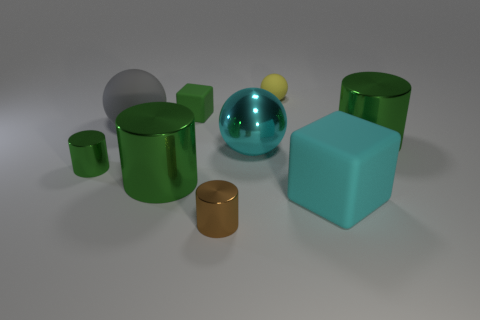How many small cylinders have the same color as the small block?
Provide a succinct answer. 1. What material is the large gray object?
Give a very brief answer. Rubber. Is the large shiny ball the same color as the big rubber cube?
Offer a terse response. Yes. There is a ball that is the same color as the large rubber block; what size is it?
Offer a very short reply. Large. There is a large ball that is made of the same material as the cyan cube; what color is it?
Ensure brevity in your answer.  Gray. Is the material of the tiny brown cylinder the same as the yellow ball behind the cyan block?
Your response must be concise. No. The large cube has what color?
Offer a terse response. Cyan. There is a green object that is made of the same material as the yellow ball; what is its size?
Your response must be concise. Small. How many things are on the right side of the tiny shiny cylinder left of the brown thing on the left side of the tiny yellow sphere?
Provide a succinct answer. 8. There is a tiny block; is it the same color as the big metallic thing that is to the left of the tiny matte block?
Your answer should be very brief. Yes. 